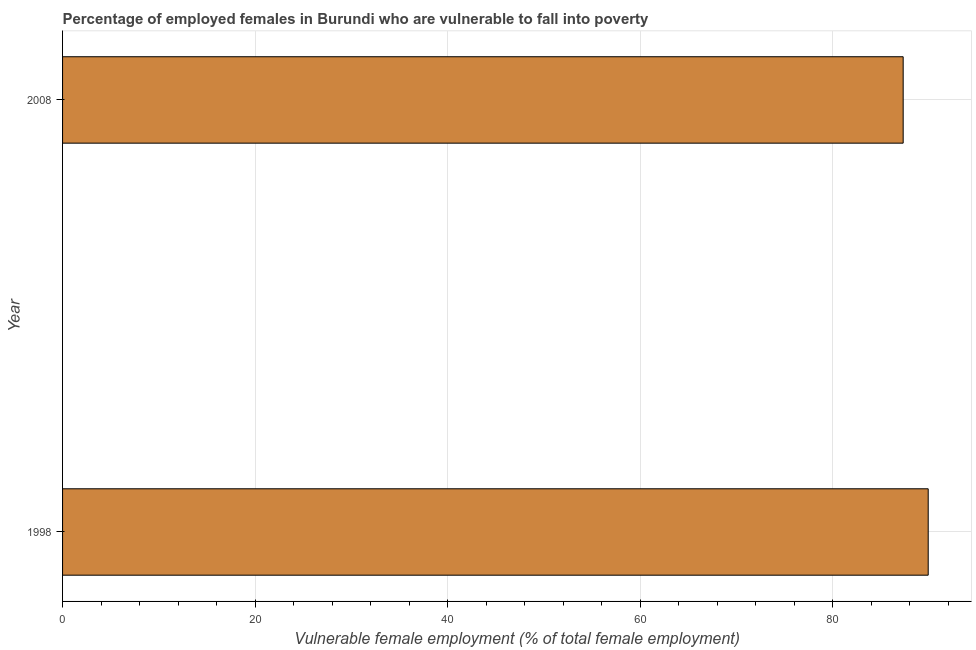Does the graph contain any zero values?
Ensure brevity in your answer.  No. What is the title of the graph?
Make the answer very short. Percentage of employed females in Burundi who are vulnerable to fall into poverty. What is the label or title of the X-axis?
Your response must be concise. Vulnerable female employment (% of total female employment). What is the percentage of employed females who are vulnerable to fall into poverty in 2008?
Give a very brief answer. 87.3. Across all years, what is the maximum percentage of employed females who are vulnerable to fall into poverty?
Your response must be concise. 89.9. Across all years, what is the minimum percentage of employed females who are vulnerable to fall into poverty?
Your response must be concise. 87.3. In which year was the percentage of employed females who are vulnerable to fall into poverty minimum?
Provide a succinct answer. 2008. What is the sum of the percentage of employed females who are vulnerable to fall into poverty?
Keep it short and to the point. 177.2. What is the average percentage of employed females who are vulnerable to fall into poverty per year?
Make the answer very short. 88.6. What is the median percentage of employed females who are vulnerable to fall into poverty?
Offer a very short reply. 88.6. In how many years, is the percentage of employed females who are vulnerable to fall into poverty greater than 64 %?
Provide a succinct answer. 2. Is the percentage of employed females who are vulnerable to fall into poverty in 1998 less than that in 2008?
Offer a terse response. No. In how many years, is the percentage of employed females who are vulnerable to fall into poverty greater than the average percentage of employed females who are vulnerable to fall into poverty taken over all years?
Provide a succinct answer. 1. What is the difference between two consecutive major ticks on the X-axis?
Provide a short and direct response. 20. What is the Vulnerable female employment (% of total female employment) in 1998?
Your answer should be compact. 89.9. What is the Vulnerable female employment (% of total female employment) in 2008?
Provide a succinct answer. 87.3. 